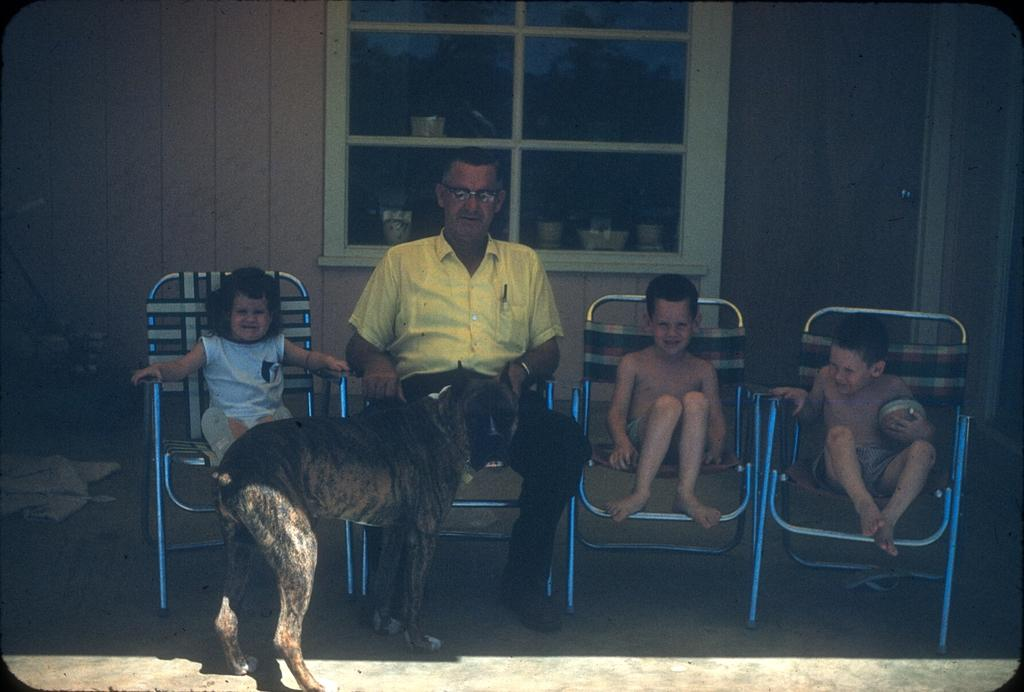Who is present in the image? There is a man and three children in the image. What are they doing in the image? The man and children are sitting on chairs. Is there any other living creature in the image? Yes, there is a dog in front of them. What can be seen behind the man and children? There is a window behind them. What is placed on the window? Objects are placed on the window. What type of volcano can be seen erupting in the image? There is no volcano present in the image. What organizations do the children belong to in the image? The image does not provide information about any organizations the children may belong to. 